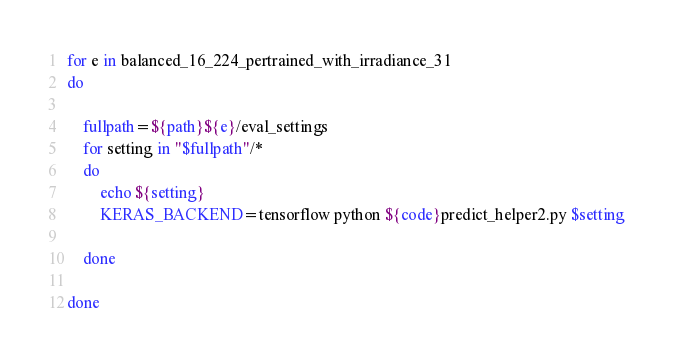Convert code to text. <code><loc_0><loc_0><loc_500><loc_500><_Bash_>

for e in balanced_16_224_pertrained_with_irradiance_31
do
	
	fullpath=${path}${e}/eval_settings
	for setting in "$fullpath"/*
	do
		echo ${setting}
		KERAS_BACKEND=tensorflow python ${code}predict_helper2.py $setting

	done
	
done
</code> 